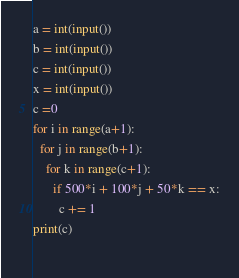Convert code to text. <code><loc_0><loc_0><loc_500><loc_500><_Python_>a = int(input())
b = int(input())
c = int(input())
x = int(input())
c =0
for i in range(a+1):
  for j in range(b+1):
    for k in range(c+1):
      if 500*i + 100*j + 50*k == x:
        c += 1
print(c)
      </code> 